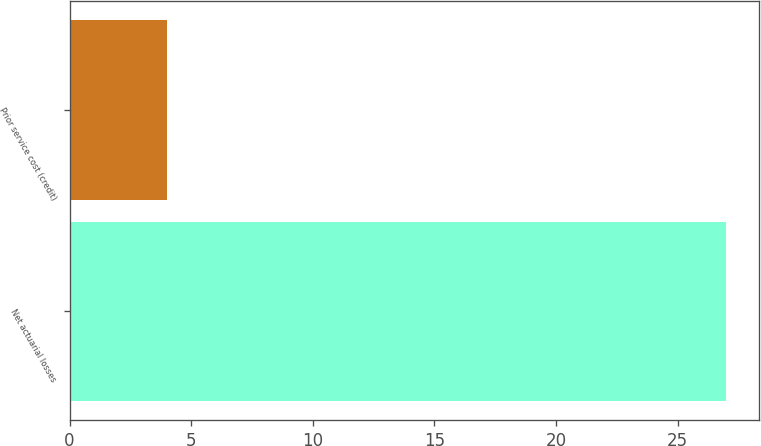Convert chart. <chart><loc_0><loc_0><loc_500><loc_500><bar_chart><fcel>Net actuarial losses<fcel>Prior service cost (credit)<nl><fcel>27<fcel>4<nl></chart> 